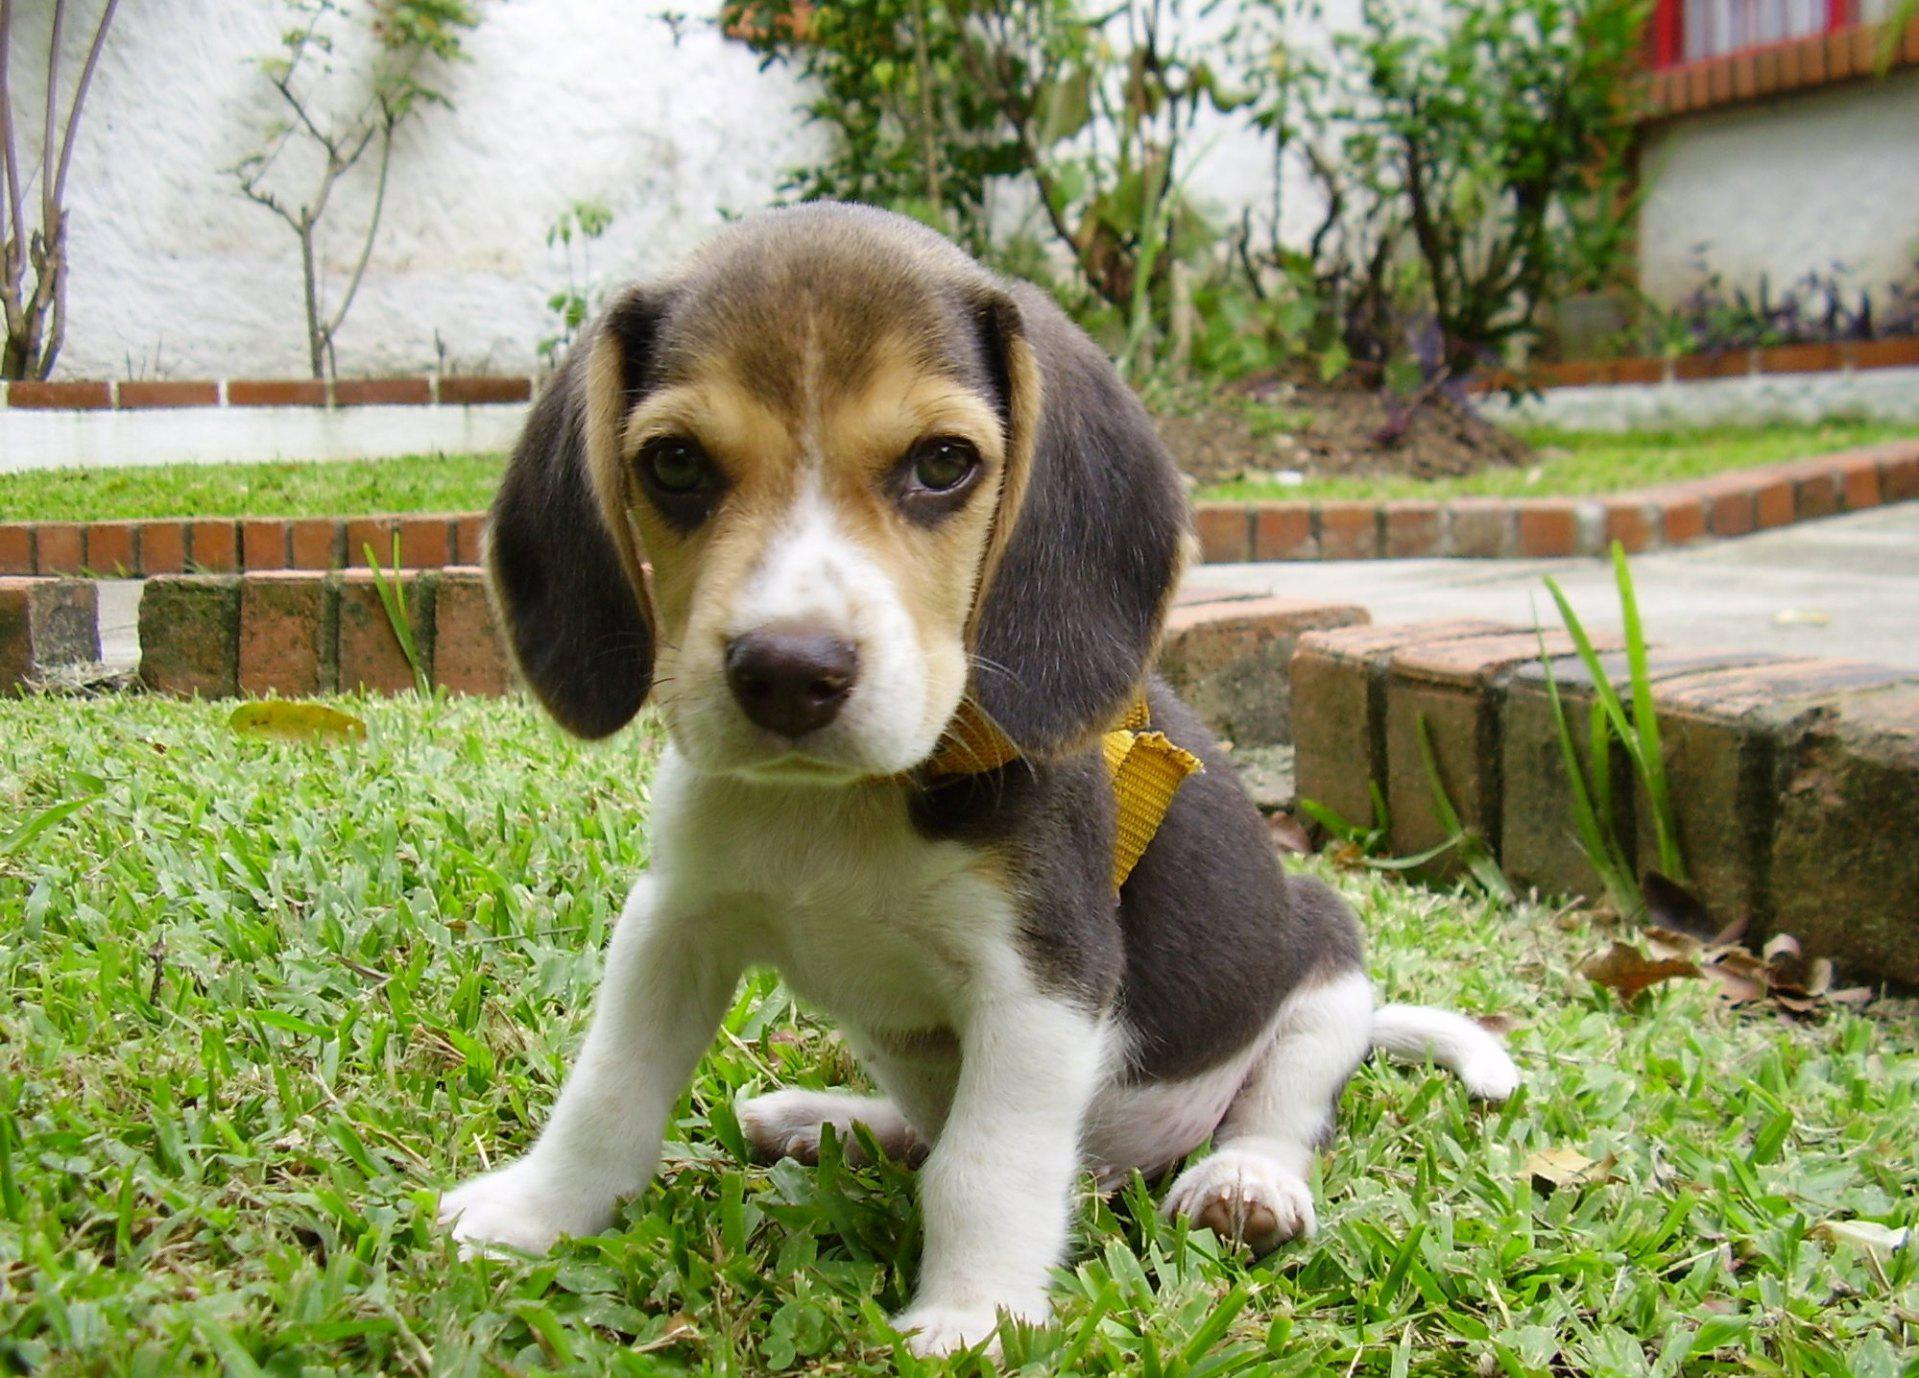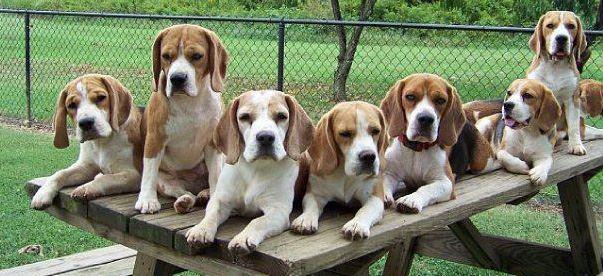The first image is the image on the left, the second image is the image on the right. For the images displayed, is the sentence "There are more than seven dogs." factually correct? Answer yes or no. Yes. The first image is the image on the left, the second image is the image on the right. For the images displayed, is the sentence "Multiple beagle dogs are posed with a rectangular wooden structure, in one image." factually correct? Answer yes or no. Yes. 